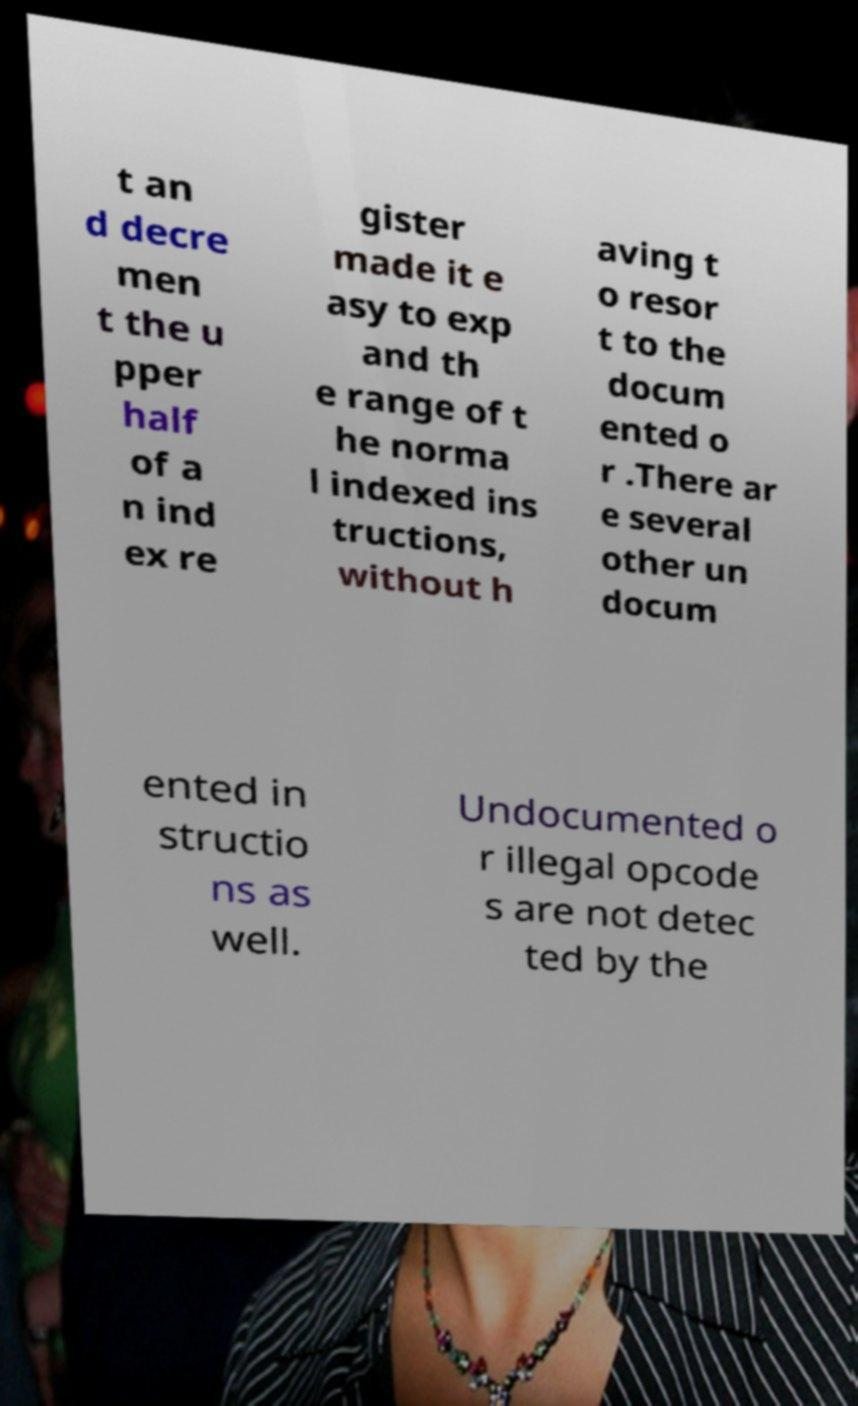Could you extract and type out the text from this image? t an d decre men t the u pper half of a n ind ex re gister made it e asy to exp and th e range of t he norma l indexed ins tructions, without h aving t o resor t to the docum ented o r .There ar e several other un docum ented in structio ns as well. Undocumented o r illegal opcode s are not detec ted by the 